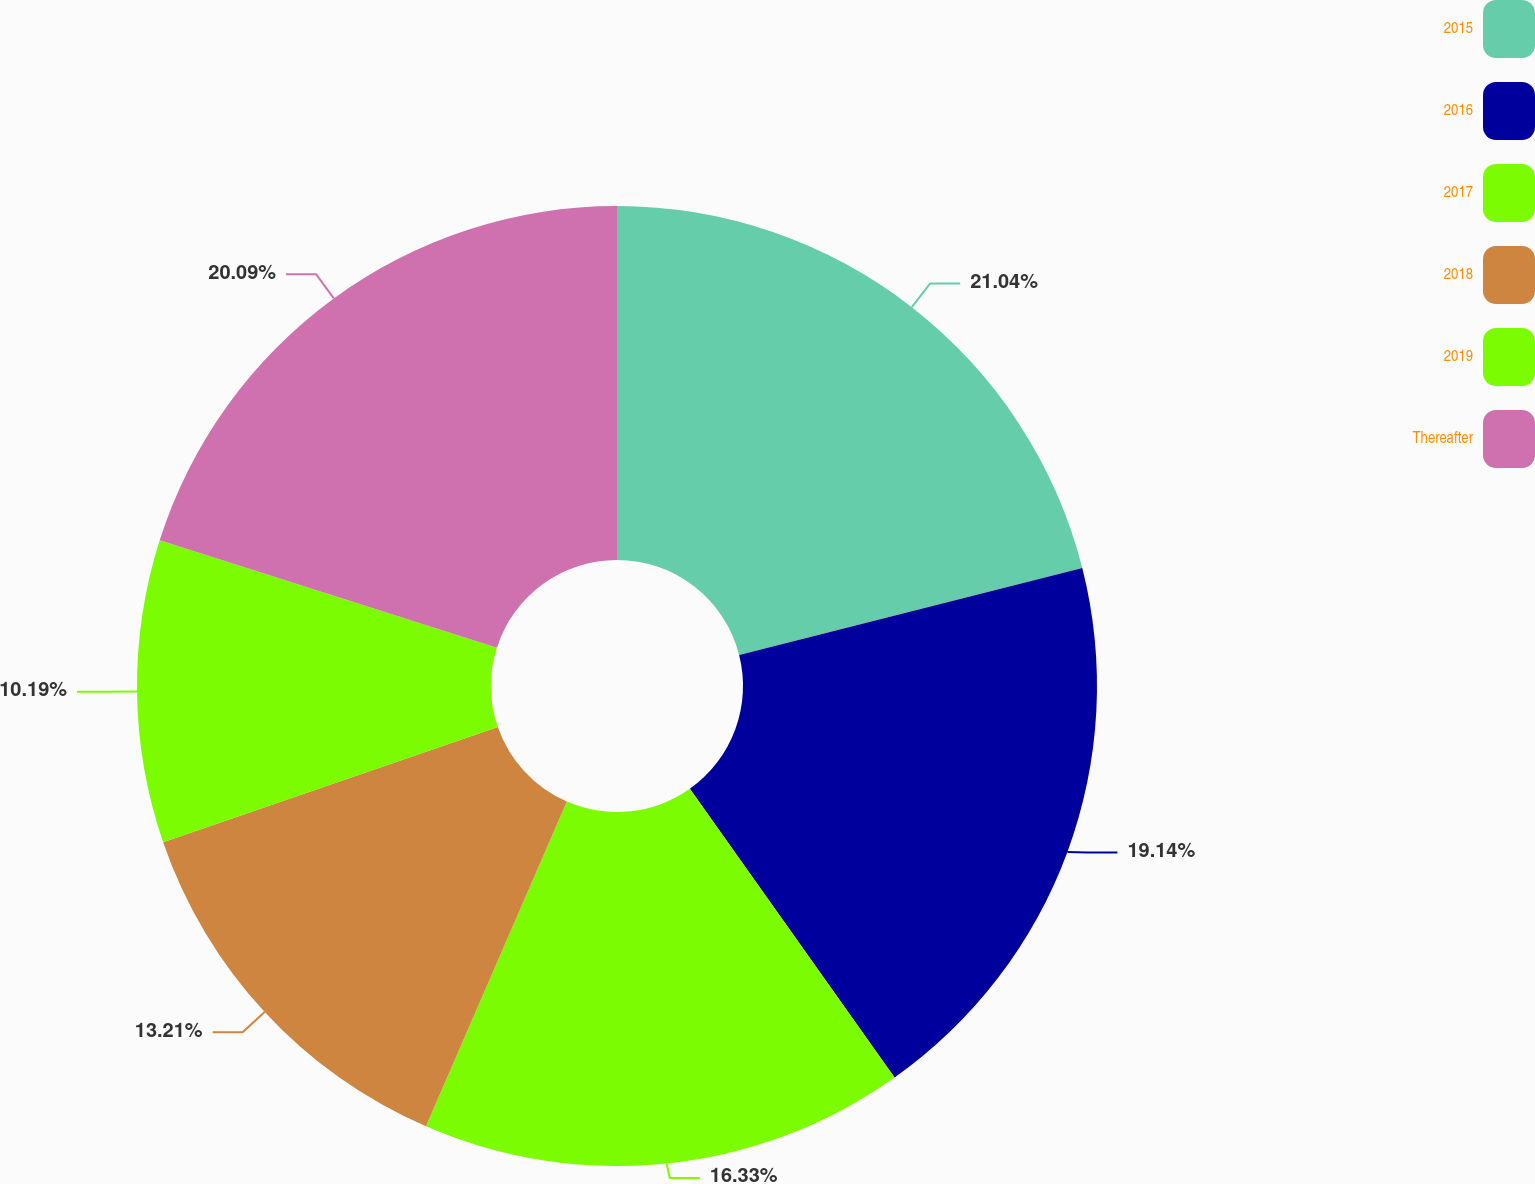Convert chart to OTSL. <chart><loc_0><loc_0><loc_500><loc_500><pie_chart><fcel>2015<fcel>2016<fcel>2017<fcel>2018<fcel>2019<fcel>Thereafter<nl><fcel>21.05%<fcel>19.14%<fcel>16.33%<fcel>13.21%<fcel>10.19%<fcel>20.09%<nl></chart> 